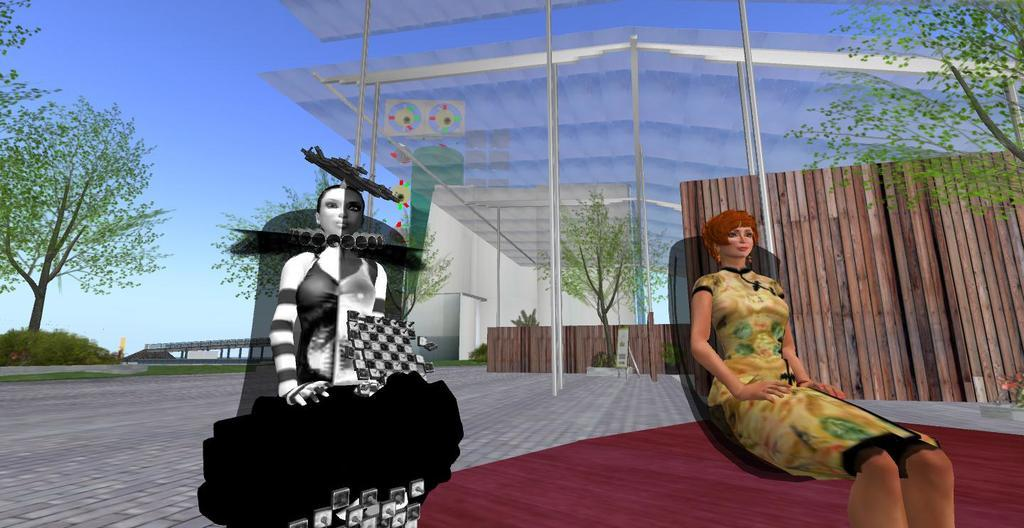How many cartoon persons are in the image? There are two cartoon persons in the image. What is the person on the right wearing? The person on the right is wearing a brown dress. What can be seen in the background of the image? There are glass doors, trees with green leaves, and a blue sky in the background. Is there any quicksand visible in the image? No, there is no quicksand present in the image. Can you see a kiss happening between the two cartoon persons in the image? There is no indication of a kiss between the two cartoon persons in the image. 